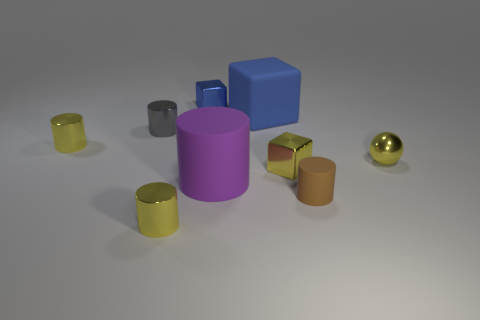How many things are tiny blocks to the left of the purple matte thing or gray cylinders?
Your answer should be very brief. 2. What is the color of the small matte cylinder?
Offer a very short reply. Brown. What is the material of the small block right of the big blue object?
Offer a very short reply. Metal. Does the tiny gray metal thing have the same shape as the shiny object on the right side of the small rubber cylinder?
Your response must be concise. No. Are there more purple matte objects than large objects?
Keep it short and to the point. No. Is there any other thing of the same color as the tiny matte cylinder?
Make the answer very short. No. There is a brown object that is the same material as the large purple cylinder; what is its shape?
Make the answer very short. Cylinder. There is a tiny yellow thing left of the yellow metal cylinder in front of the yellow ball; what is it made of?
Provide a short and direct response. Metal. Does the yellow shiny thing in front of the purple matte thing have the same shape as the tiny gray object?
Make the answer very short. Yes. Is the number of small yellow objects that are on the left side of the small yellow metallic ball greater than the number of shiny cylinders?
Offer a very short reply. No. 